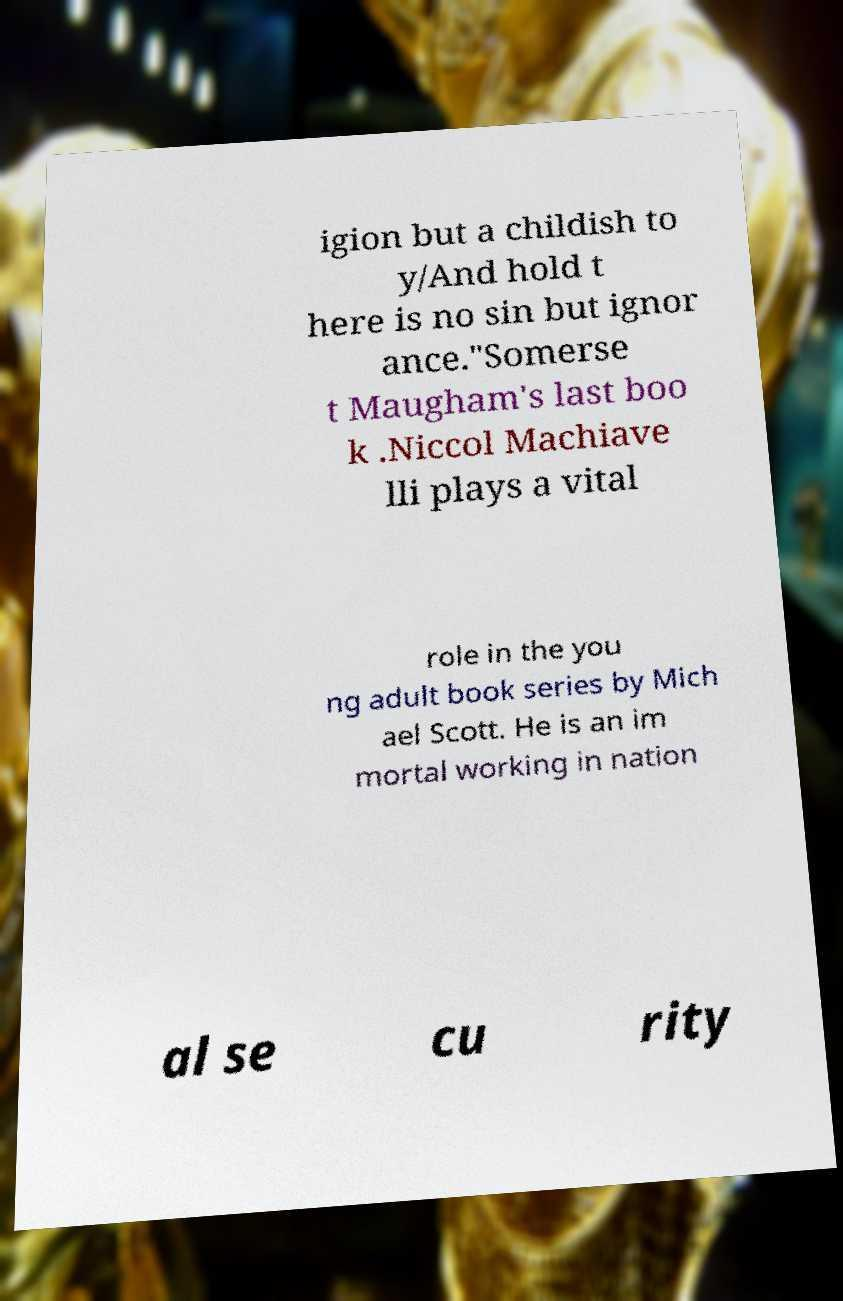Please identify and transcribe the text found in this image. igion but a childish to y/And hold t here is no sin but ignor ance."Somerse t Maugham's last boo k .Niccol Machiave lli plays a vital role in the you ng adult book series by Mich ael Scott. He is an im mortal working in nation al se cu rity 